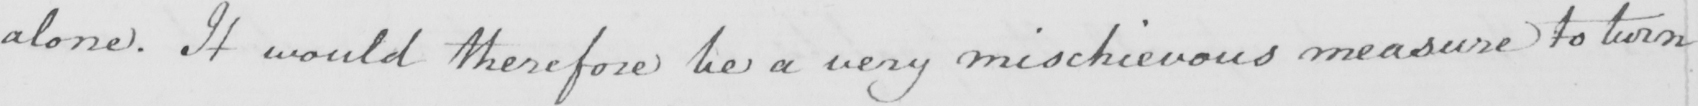Can you read and transcribe this handwriting? alone . It would therefore be a very mischievous measure to turn 